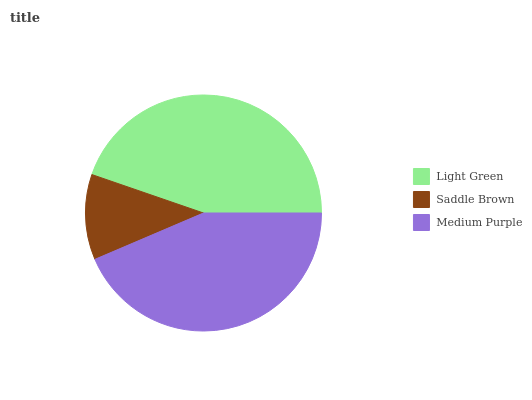Is Saddle Brown the minimum?
Answer yes or no. Yes. Is Light Green the maximum?
Answer yes or no. Yes. Is Medium Purple the minimum?
Answer yes or no. No. Is Medium Purple the maximum?
Answer yes or no. No. Is Medium Purple greater than Saddle Brown?
Answer yes or no. Yes. Is Saddle Brown less than Medium Purple?
Answer yes or no. Yes. Is Saddle Brown greater than Medium Purple?
Answer yes or no. No. Is Medium Purple less than Saddle Brown?
Answer yes or no. No. Is Medium Purple the high median?
Answer yes or no. Yes. Is Medium Purple the low median?
Answer yes or no. Yes. Is Light Green the high median?
Answer yes or no. No. Is Light Green the low median?
Answer yes or no. No. 